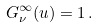Convert formula to latex. <formula><loc_0><loc_0><loc_500><loc_500>G ^ { \infty } _ { \nu } ( u ) = 1 \, .</formula> 